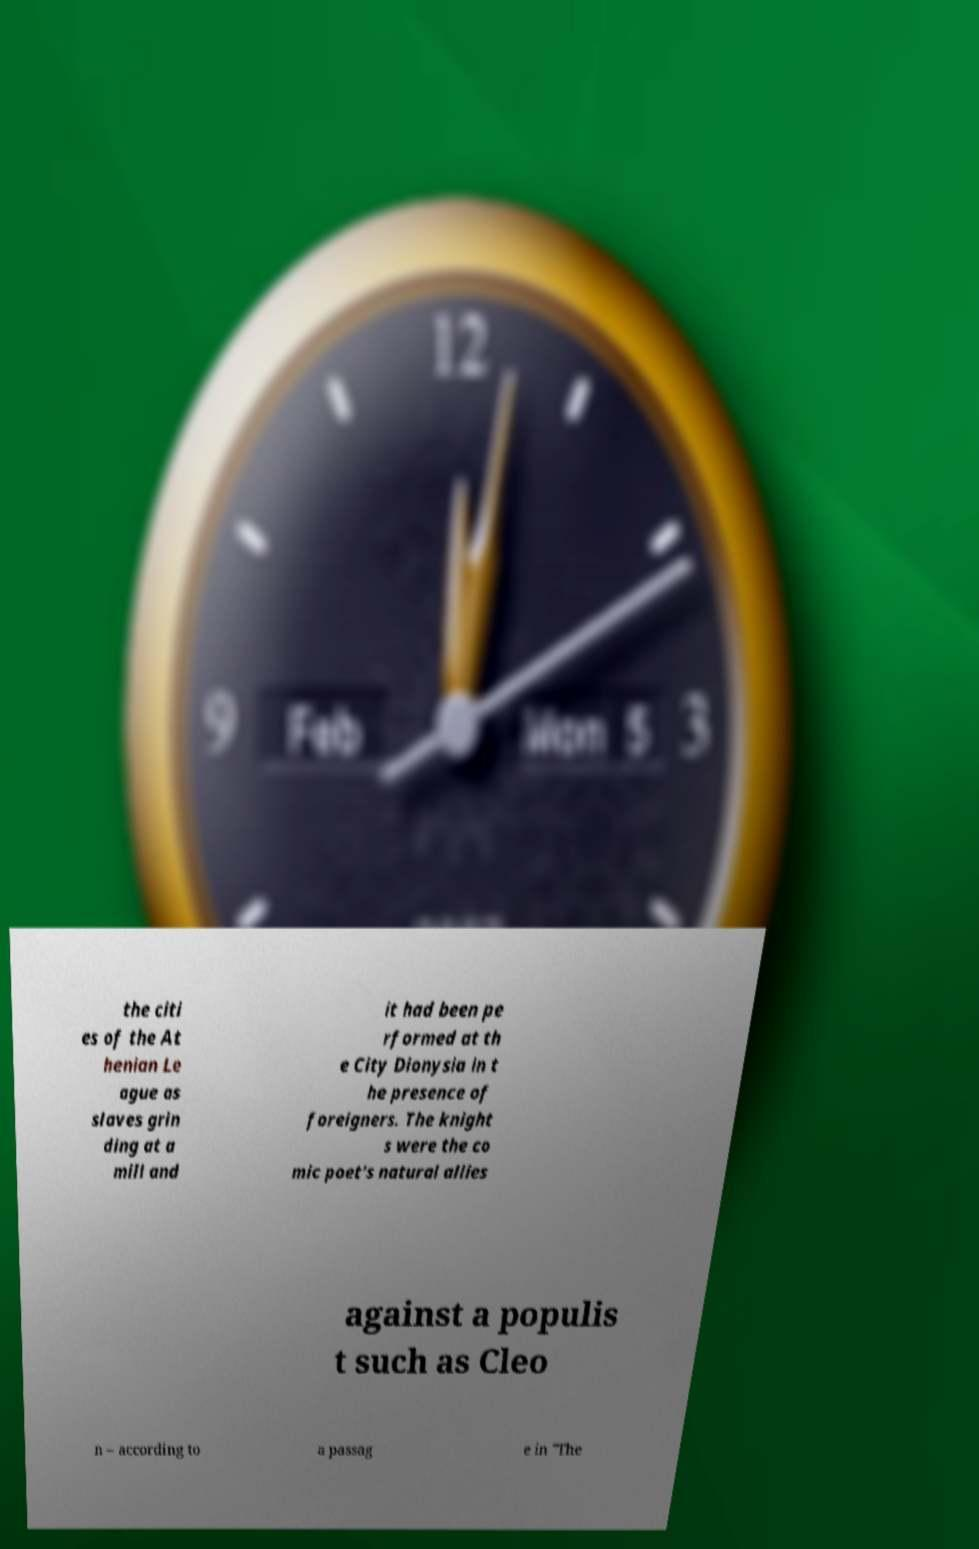Could you extract and type out the text from this image? the citi es of the At henian Le ague as slaves grin ding at a mill and it had been pe rformed at th e City Dionysia in t he presence of foreigners. The knight s were the co mic poet's natural allies against a populis t such as Cleo n – according to a passag e in "The 